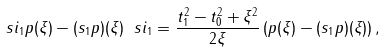Convert formula to latex. <formula><loc_0><loc_0><loc_500><loc_500>\ s i _ { 1 } p ( \xi ) - ( s _ { 1 } p ) ( \xi ) \ s i _ { 1 } = \frac { t _ { 1 } ^ { 2 } - t _ { 0 } ^ { 2 } + \xi ^ { 2 } } { 2 \xi } \left ( p ( \xi ) - ( s _ { 1 } p ) ( \xi ) \right ) ,</formula> 